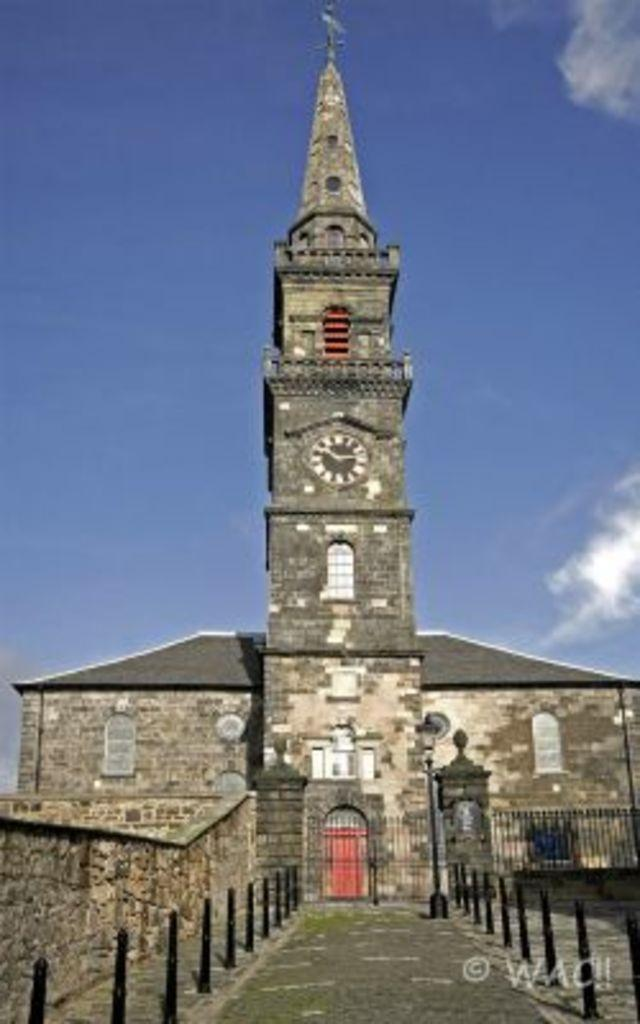What type of structure is in the image? There is a building in the image. What feature stands out in the middle of the building? The building has a tower in the middle. What is located in front of the building? There is a road in front of the building. What can be seen above the building? The sky is visible above the building. What is present in the sky? Clouds are present in the sky. What type of jeans is the building wearing in the image? Buildings do not wear jeans, as they are inanimate structures. 